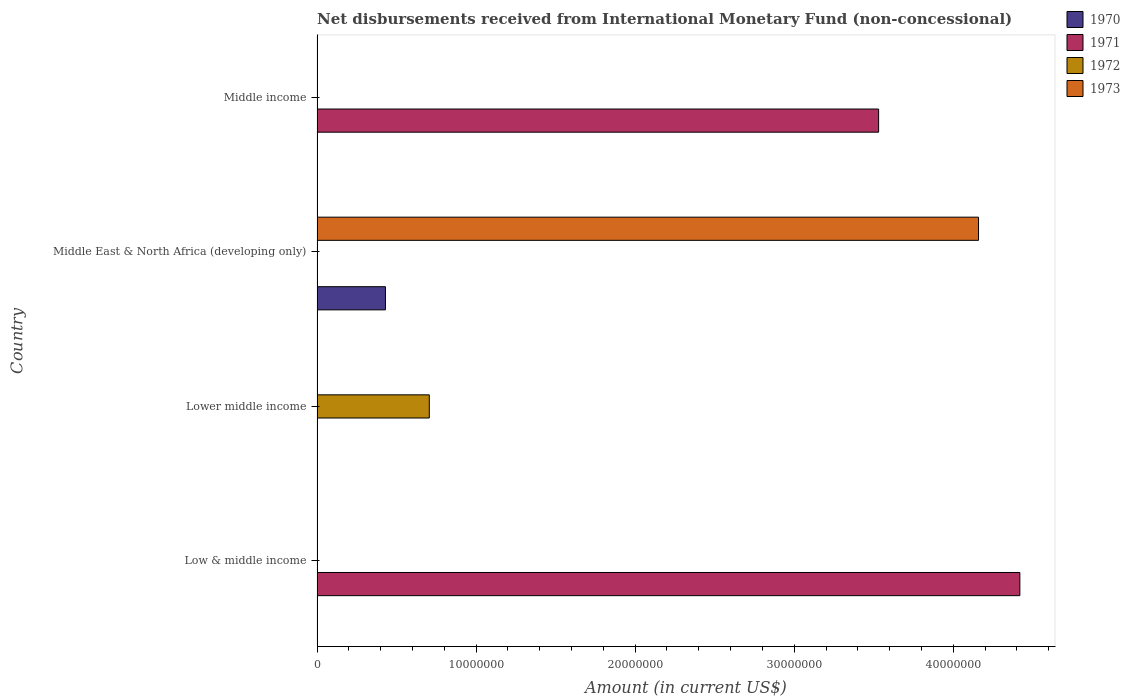Are the number of bars on each tick of the Y-axis equal?
Make the answer very short. No. How many bars are there on the 4th tick from the top?
Ensure brevity in your answer.  1. How many bars are there on the 4th tick from the bottom?
Offer a terse response. 1. What is the label of the 1st group of bars from the top?
Offer a terse response. Middle income. In how many cases, is the number of bars for a given country not equal to the number of legend labels?
Provide a succinct answer. 4. Across all countries, what is the maximum amount of disbursements received from International Monetary Fund in 1972?
Offer a terse response. 7.06e+06. Across all countries, what is the minimum amount of disbursements received from International Monetary Fund in 1972?
Keep it short and to the point. 0. In which country was the amount of disbursements received from International Monetary Fund in 1973 maximum?
Ensure brevity in your answer.  Middle East & North Africa (developing only). What is the total amount of disbursements received from International Monetary Fund in 1972 in the graph?
Offer a very short reply. 7.06e+06. What is the difference between the amount of disbursements received from International Monetary Fund in 1971 in Lower middle income and the amount of disbursements received from International Monetary Fund in 1970 in Middle East & North Africa (developing only)?
Provide a short and direct response. -4.30e+06. What is the average amount of disbursements received from International Monetary Fund in 1971 per country?
Give a very brief answer. 1.99e+07. In how many countries, is the amount of disbursements received from International Monetary Fund in 1972 greater than 2000000 US$?
Offer a very short reply. 1. What is the difference between the highest and the lowest amount of disbursements received from International Monetary Fund in 1971?
Offer a very short reply. 4.42e+07. In how many countries, is the amount of disbursements received from International Monetary Fund in 1973 greater than the average amount of disbursements received from International Monetary Fund in 1973 taken over all countries?
Keep it short and to the point. 1. Is it the case that in every country, the sum of the amount of disbursements received from International Monetary Fund in 1972 and amount of disbursements received from International Monetary Fund in 1973 is greater than the amount of disbursements received from International Monetary Fund in 1971?
Give a very brief answer. No. Are all the bars in the graph horizontal?
Give a very brief answer. Yes. Are the values on the major ticks of X-axis written in scientific E-notation?
Make the answer very short. No. Does the graph contain any zero values?
Give a very brief answer. Yes. Where does the legend appear in the graph?
Offer a very short reply. Top right. How many legend labels are there?
Your answer should be very brief. 4. What is the title of the graph?
Your response must be concise. Net disbursements received from International Monetary Fund (non-concessional). Does "1976" appear as one of the legend labels in the graph?
Give a very brief answer. No. What is the label or title of the Y-axis?
Provide a short and direct response. Country. What is the Amount (in current US$) in 1971 in Low & middle income?
Provide a short and direct response. 4.42e+07. What is the Amount (in current US$) in 1972 in Low & middle income?
Your answer should be compact. 0. What is the Amount (in current US$) of 1970 in Lower middle income?
Keep it short and to the point. 0. What is the Amount (in current US$) of 1972 in Lower middle income?
Give a very brief answer. 7.06e+06. What is the Amount (in current US$) in 1973 in Lower middle income?
Provide a succinct answer. 0. What is the Amount (in current US$) of 1970 in Middle East & North Africa (developing only)?
Give a very brief answer. 4.30e+06. What is the Amount (in current US$) of 1971 in Middle East & North Africa (developing only)?
Your answer should be very brief. 0. What is the Amount (in current US$) of 1973 in Middle East & North Africa (developing only)?
Provide a short and direct response. 4.16e+07. What is the Amount (in current US$) of 1970 in Middle income?
Provide a succinct answer. 0. What is the Amount (in current US$) of 1971 in Middle income?
Offer a terse response. 3.53e+07. Across all countries, what is the maximum Amount (in current US$) of 1970?
Make the answer very short. 4.30e+06. Across all countries, what is the maximum Amount (in current US$) in 1971?
Ensure brevity in your answer.  4.42e+07. Across all countries, what is the maximum Amount (in current US$) in 1972?
Your answer should be very brief. 7.06e+06. Across all countries, what is the maximum Amount (in current US$) of 1973?
Provide a succinct answer. 4.16e+07. Across all countries, what is the minimum Amount (in current US$) of 1970?
Offer a terse response. 0. Across all countries, what is the minimum Amount (in current US$) in 1973?
Make the answer very short. 0. What is the total Amount (in current US$) of 1970 in the graph?
Give a very brief answer. 4.30e+06. What is the total Amount (in current US$) in 1971 in the graph?
Your response must be concise. 7.95e+07. What is the total Amount (in current US$) of 1972 in the graph?
Your answer should be very brief. 7.06e+06. What is the total Amount (in current US$) in 1973 in the graph?
Ensure brevity in your answer.  4.16e+07. What is the difference between the Amount (in current US$) of 1971 in Low & middle income and that in Middle income?
Your answer should be compact. 8.88e+06. What is the difference between the Amount (in current US$) in 1971 in Low & middle income and the Amount (in current US$) in 1972 in Lower middle income?
Your answer should be compact. 3.71e+07. What is the difference between the Amount (in current US$) in 1971 in Low & middle income and the Amount (in current US$) in 1973 in Middle East & North Africa (developing only)?
Ensure brevity in your answer.  2.60e+06. What is the difference between the Amount (in current US$) in 1972 in Lower middle income and the Amount (in current US$) in 1973 in Middle East & North Africa (developing only)?
Offer a very short reply. -3.45e+07. What is the difference between the Amount (in current US$) of 1970 in Middle East & North Africa (developing only) and the Amount (in current US$) of 1971 in Middle income?
Provide a succinct answer. -3.10e+07. What is the average Amount (in current US$) of 1970 per country?
Offer a very short reply. 1.08e+06. What is the average Amount (in current US$) of 1971 per country?
Your response must be concise. 1.99e+07. What is the average Amount (in current US$) of 1972 per country?
Make the answer very short. 1.76e+06. What is the average Amount (in current US$) in 1973 per country?
Ensure brevity in your answer.  1.04e+07. What is the difference between the Amount (in current US$) in 1970 and Amount (in current US$) in 1973 in Middle East & North Africa (developing only)?
Your answer should be compact. -3.73e+07. What is the ratio of the Amount (in current US$) in 1971 in Low & middle income to that in Middle income?
Keep it short and to the point. 1.25. What is the difference between the highest and the lowest Amount (in current US$) in 1970?
Provide a short and direct response. 4.30e+06. What is the difference between the highest and the lowest Amount (in current US$) of 1971?
Keep it short and to the point. 4.42e+07. What is the difference between the highest and the lowest Amount (in current US$) of 1972?
Ensure brevity in your answer.  7.06e+06. What is the difference between the highest and the lowest Amount (in current US$) of 1973?
Your response must be concise. 4.16e+07. 